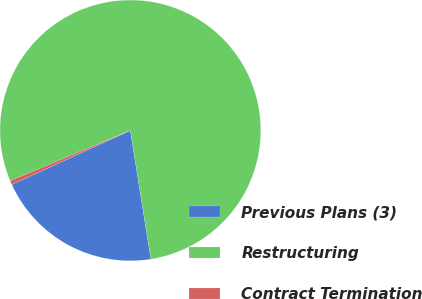Convert chart. <chart><loc_0><loc_0><loc_500><loc_500><pie_chart><fcel>Previous Plans (3)<fcel>Restructuring<fcel>Contract Termination<nl><fcel>20.71%<fcel>78.8%<fcel>0.49%<nl></chart> 